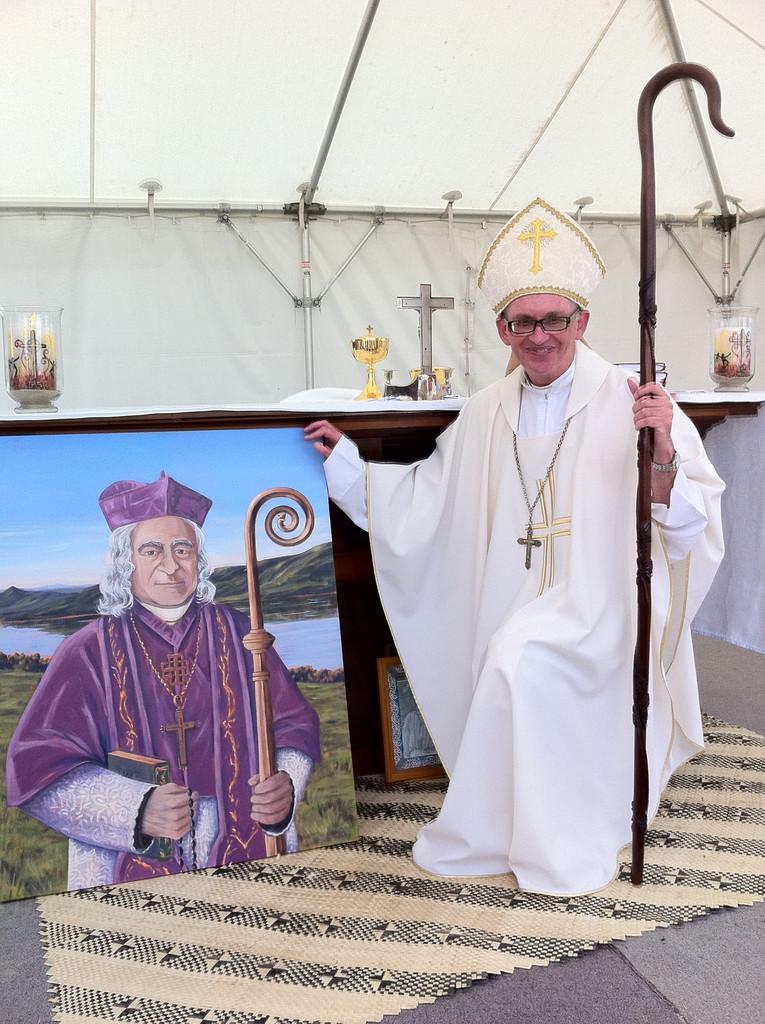Can you describe this image briefly? In this image I can see a priest holding a stick and there is a painting of a person on the left. There is a canopy at the back. 